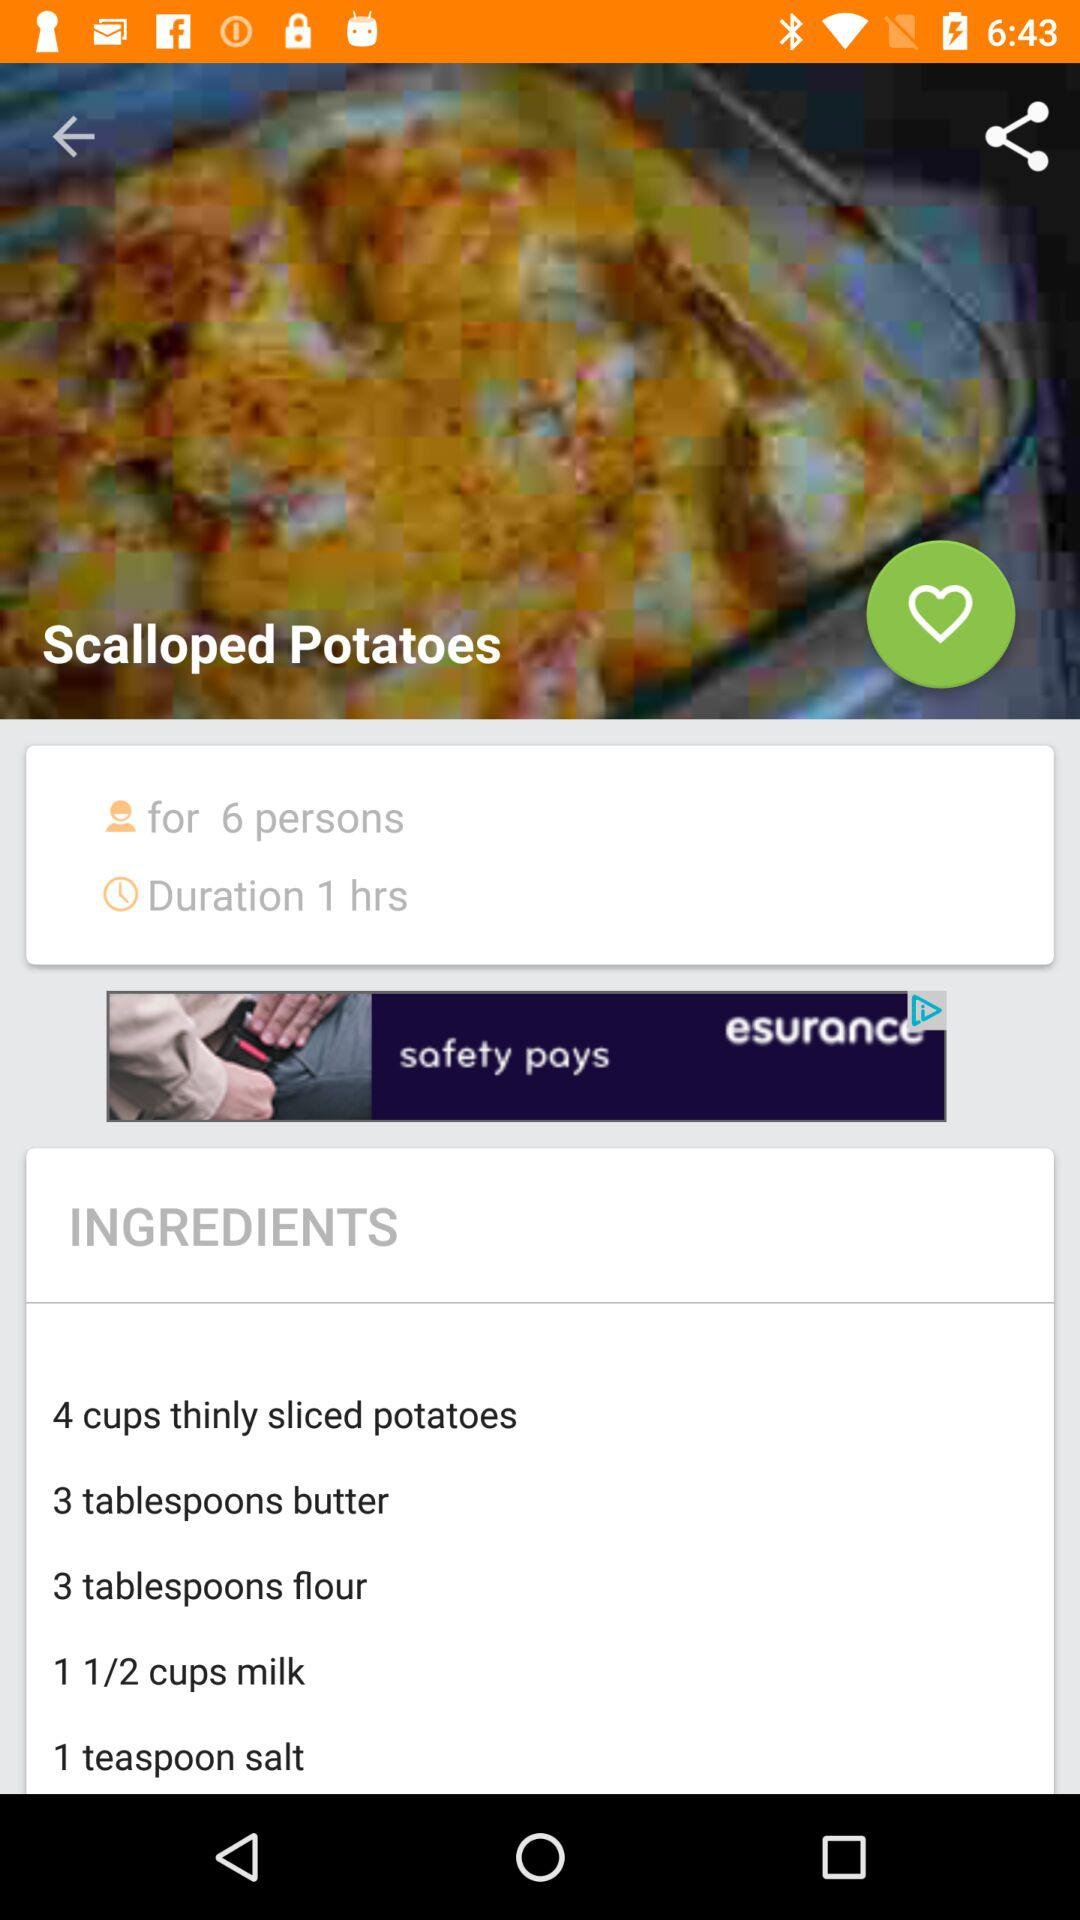How many people can the "Scalloped Potatoes" be served to? The "Scalloped Potatoes" can be served to 6 people. 